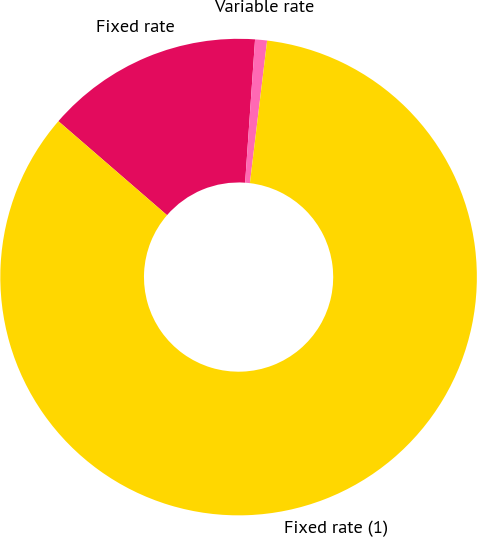Convert chart. <chart><loc_0><loc_0><loc_500><loc_500><pie_chart><fcel>Fixed rate<fcel>Variable rate<fcel>Fixed rate (1)<nl><fcel>14.75%<fcel>0.81%<fcel>84.44%<nl></chart> 